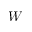Convert formula to latex. <formula><loc_0><loc_0><loc_500><loc_500>W</formula> 